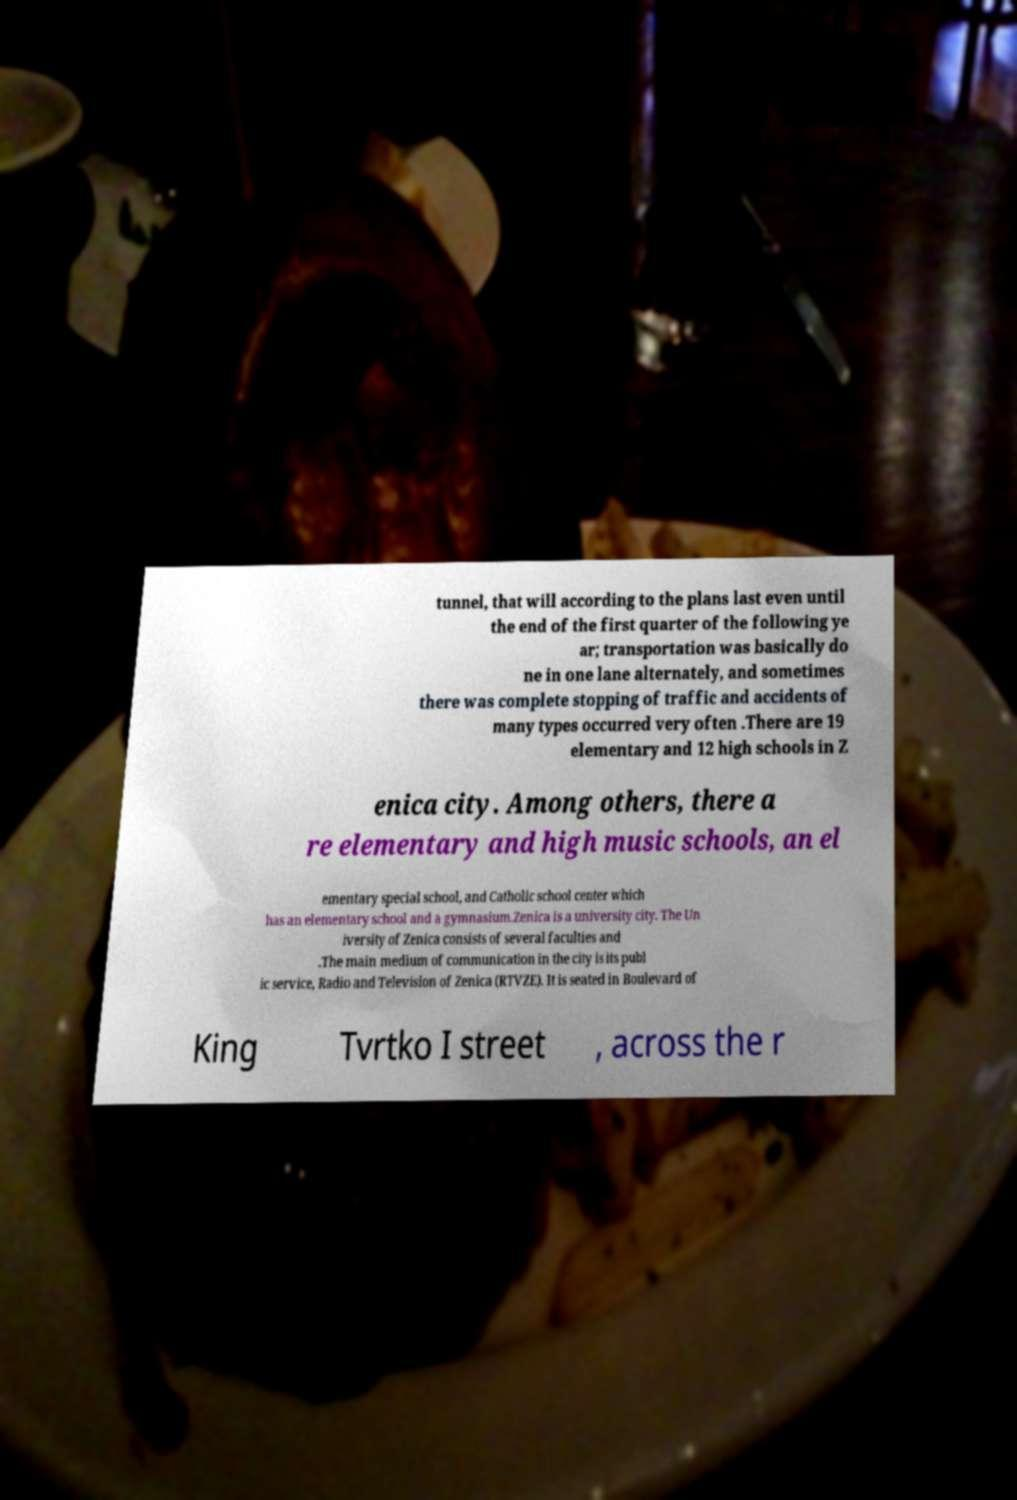Could you assist in decoding the text presented in this image and type it out clearly? tunnel, that will according to the plans last even until the end of the first quarter of the following ye ar; transportation was basically do ne in one lane alternately, and sometimes there was complete stopping of traffic and accidents of many types occurred very often .There are 19 elementary and 12 high schools in Z enica city. Among others, there a re elementary and high music schools, an el ementary special school, and Catholic school center which has an elementary school and a gymnasium.Zenica is a university city. The Un iversity of Zenica consists of several faculties and .The main medium of communication in the city is its publ ic service, Radio and Television of Zenica (RTVZE). It is seated in Boulevard of King Tvrtko I street , across the r 